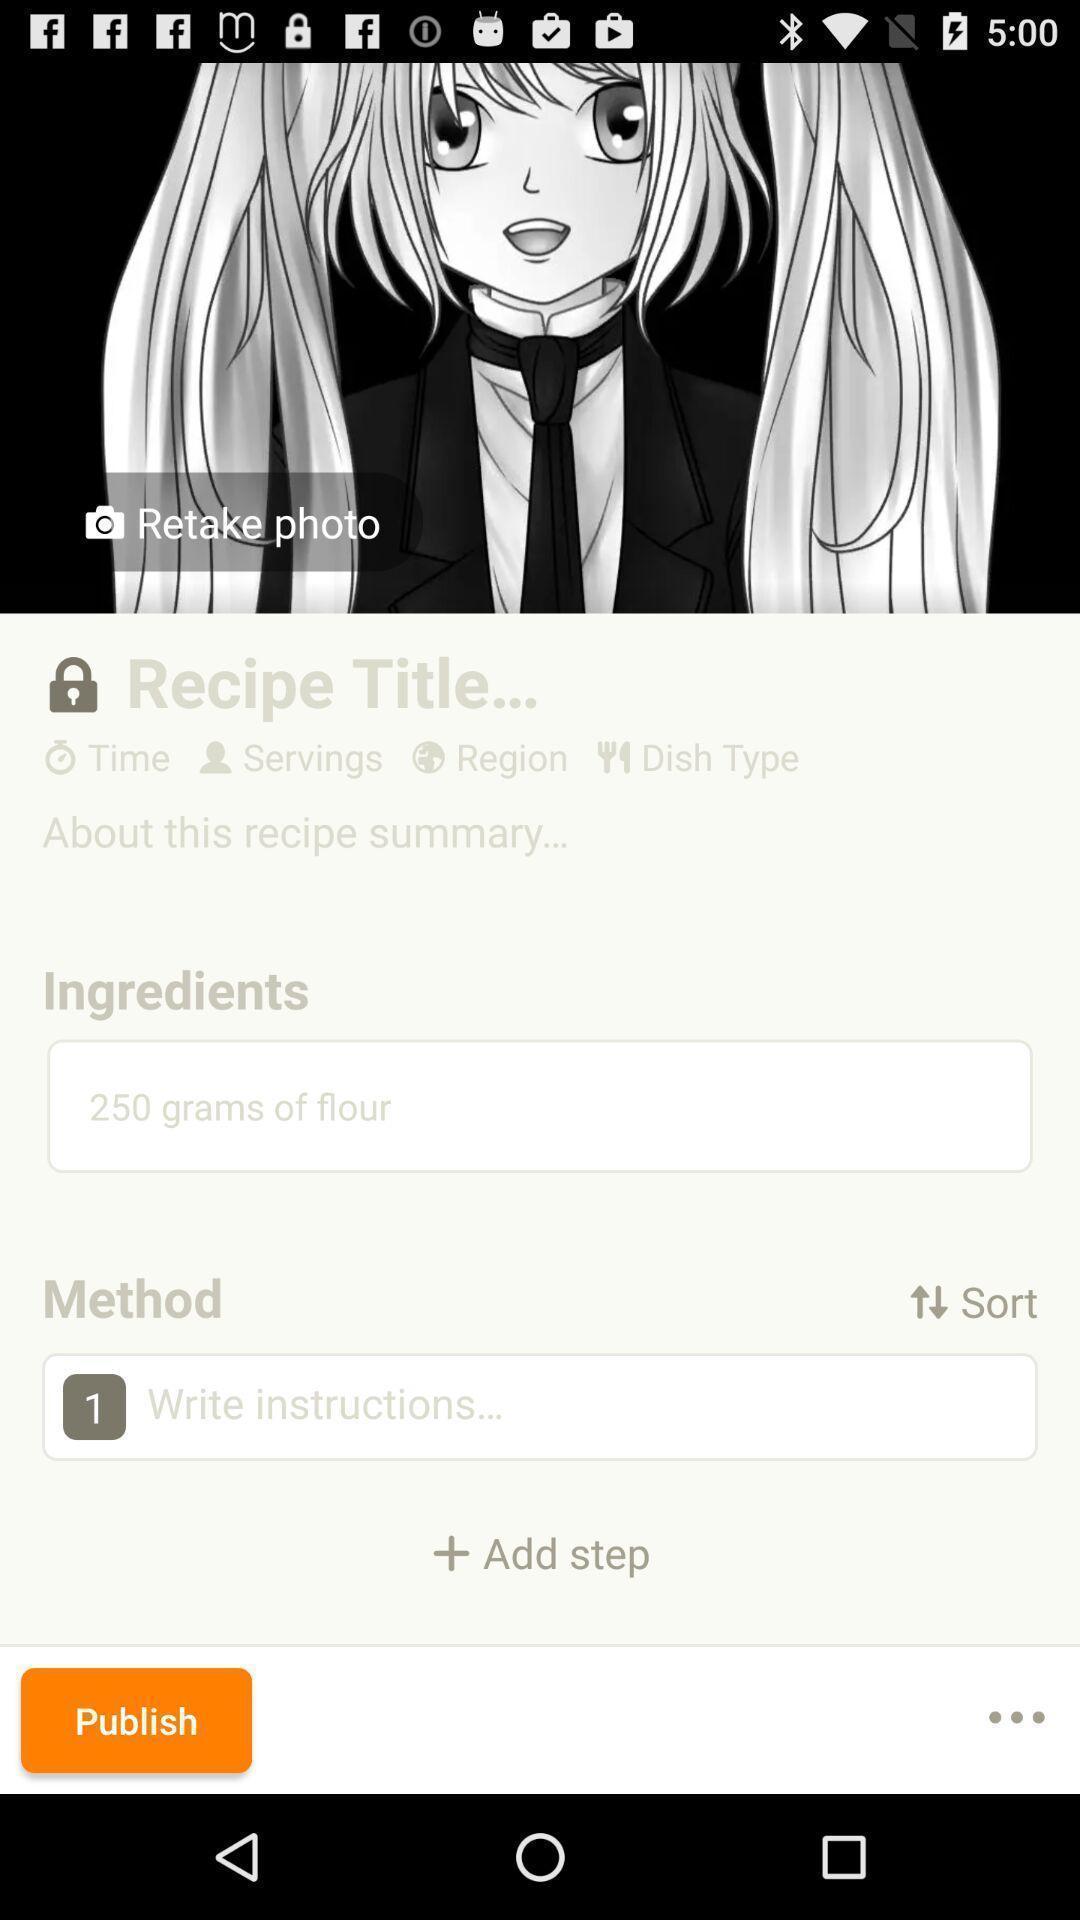Give me a narrative description of this picture. Screen shows multiple details in a food application. 